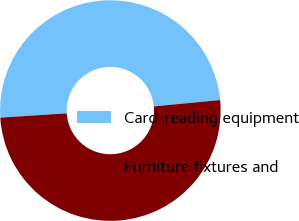<chart> <loc_0><loc_0><loc_500><loc_500><pie_chart><fcel>Card-reading equipment<fcel>Furniture fixtures and<nl><fcel>49.5%<fcel>50.5%<nl></chart> 